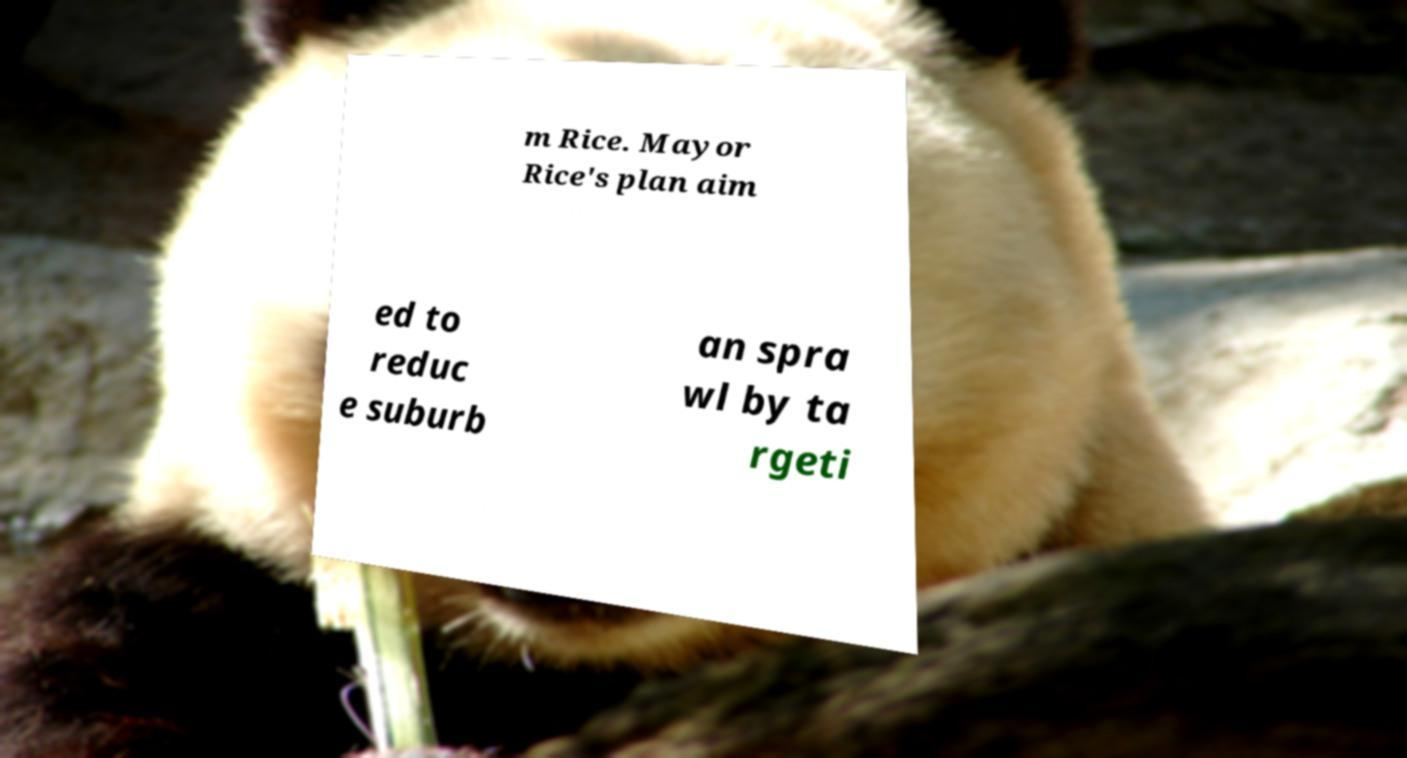For documentation purposes, I need the text within this image transcribed. Could you provide that? m Rice. Mayor Rice's plan aim ed to reduc e suburb an spra wl by ta rgeti 